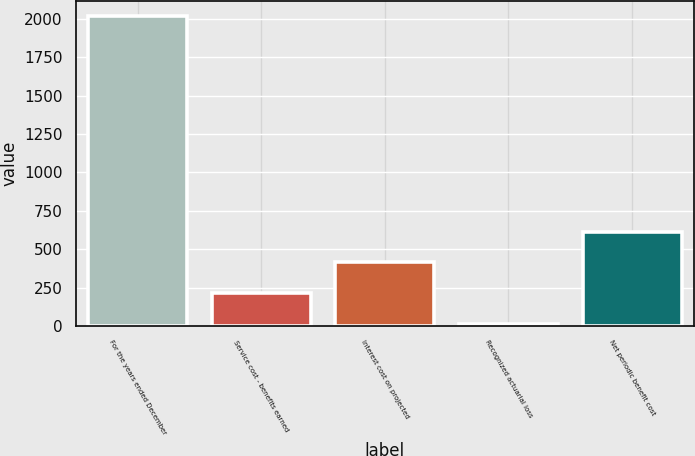<chart> <loc_0><loc_0><loc_500><loc_500><bar_chart><fcel>For the years ended December<fcel>Service cost - benefits earned<fcel>Interest cost on projected<fcel>Recognized actuarial loss<fcel>Net periodic benefit cost<nl><fcel>2016<fcel>215.1<fcel>415.2<fcel>15<fcel>615.3<nl></chart> 